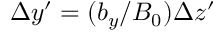<formula> <loc_0><loc_0><loc_500><loc_500>\Delta y ^ { \prime } = ( b _ { y } / B _ { 0 } ) \Delta z ^ { \prime }</formula> 